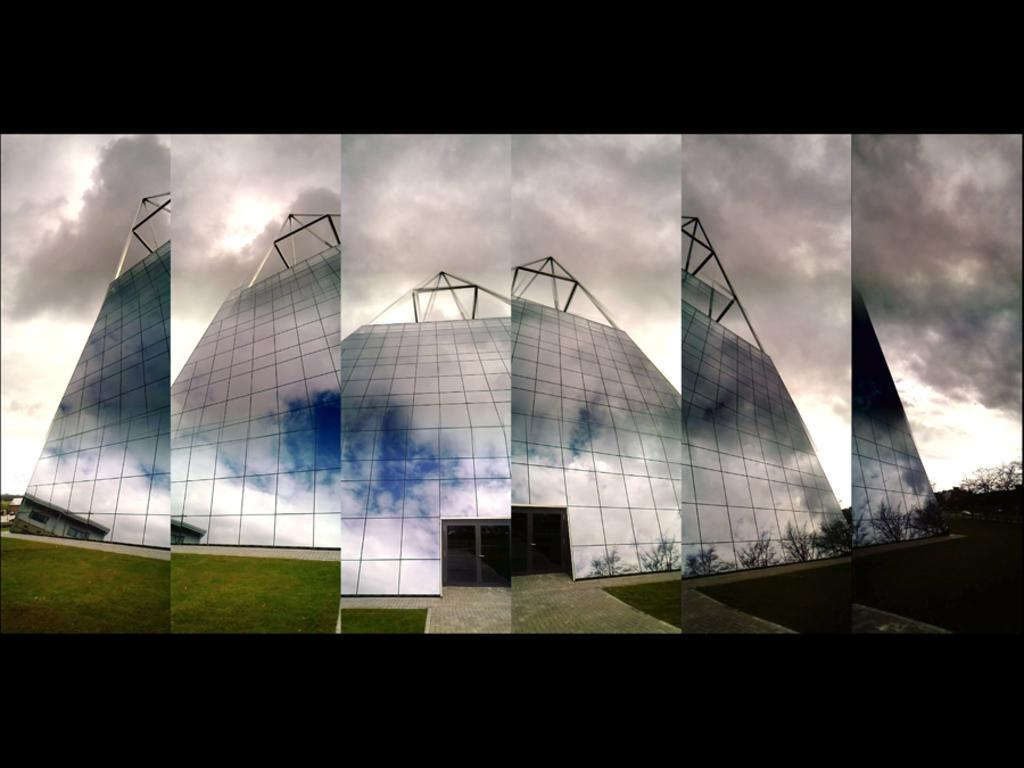What type of image is being described? The image is a collage of six images. What is the common feature in each of the six images? Each image contains a glass building. What can be seen in the background of the images? There are clouds in the sky in the background of the images. What type of wax is being used to create the glass buildings in the image? There is no wax present in the image; the glass buildings are depicted in photographs or illustrations. What type of office furniture can be seen in the image? There is no office furniture visible in the image, as it only contains images of glass buildings and clouds in the sky. 